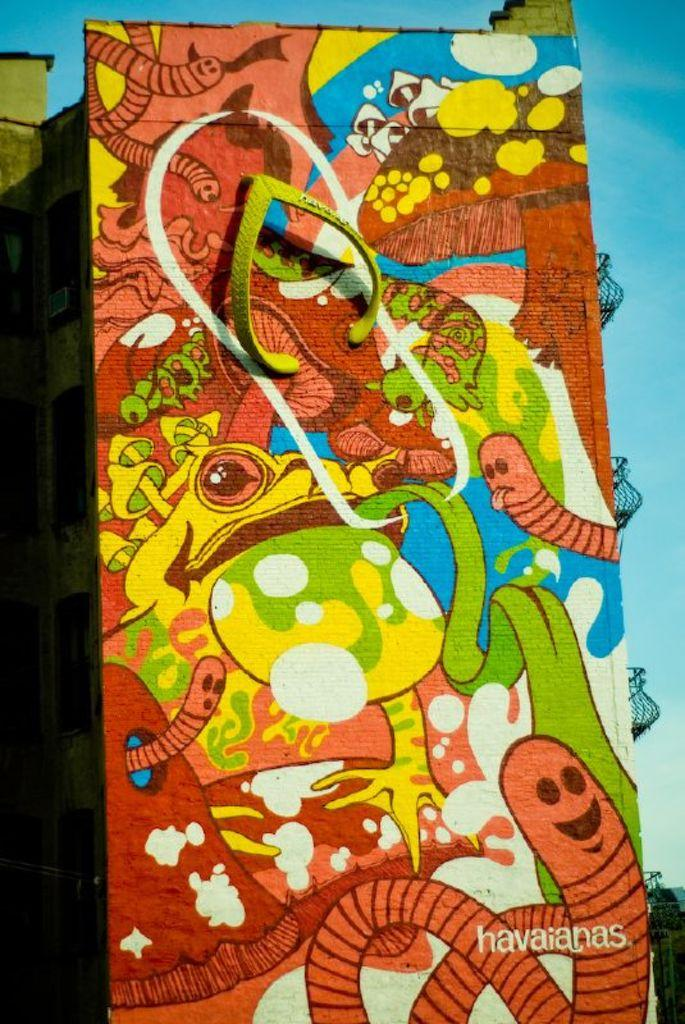<image>
Offer a succinct explanation of the picture presented. A sign for havaianas has a frog, mushrooms, and worms on it. 